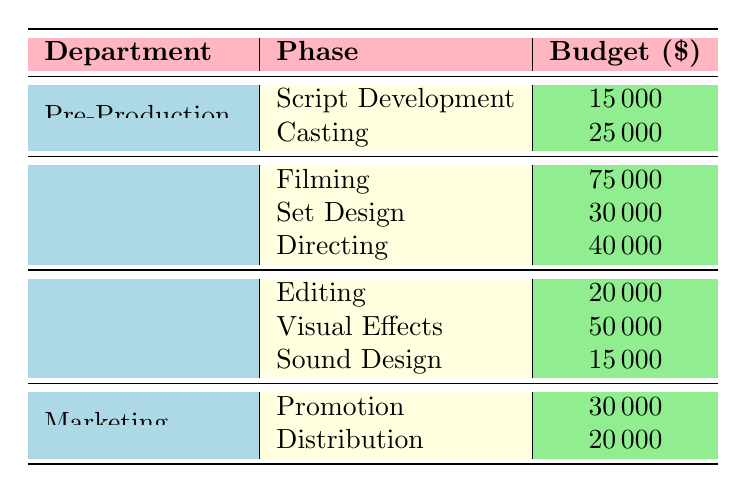What is the budget allocated for Filming in the Production department? The budget allocated for Filming is specifically listed under the Production department in the table. It shows a value of 75000.
Answer: 75000 Which department has the highest single-phase budget allocation? Looking through the table, the Production department has Filming with a budget of 75000, which is the highest value compared to other phases and departments.
Answer: Production (Filming) What is the total budget for the Post-Production department? To find the total budget for Post-Production, I need to sum the budgets for all its phases: Editing (20000) + Visual Effects (50000) + Sound Design (15000) = 85000.
Answer: 85000 Is the budget for Casting greater than the budget for Sound Design? The budget for Casting in Pre-Production is 25000 and for Sound Design in Post-Production it is 15000. Since 25000 is greater than 15000, the statement is true.
Answer: Yes What is the average budget allocated for the Marketing department? In the Marketing department, the phases are Promotion (30000) and Distribution (20000). First, sum these budgets: 30000 + 20000 = 50000. Then, divide by the number of phases (2) to get the average: 50000 / 2 = 25000.
Answer: 25000 What is the combined budget for all phases in the Production department? The budgets in the Production department are Filming (75000), Set Design (30000), and Directing (40000). Summing these yields: 75000 + 30000 + 40000 = 145000.
Answer: 145000 Does the total budget for Pre-Production exceed that of Marketing? The total budget for Pre-Production is 15000 (Script Development) + 25000 (Casting) = 40000. The total for Marketing is 30000 (Promotion) + 20000 (Distribution) = 50000. Since 40000 does not exceed 50000, the answer is no.
Answer: No What is the difference in budget between the highest and lowest budget phases in Post-Production? The highest budget in Post-Production is for Visual Effects (50000) and the lowest is for Sound Design (15000). Therefore, the difference is calculated as: 50000 - 15000 = 35000.
Answer: 35000 How many total budget entries are there in the table? To find the total number of budget entries, count each individual row in the table which lists a phase and its associated budget. There are 10 entries.
Answer: 10 